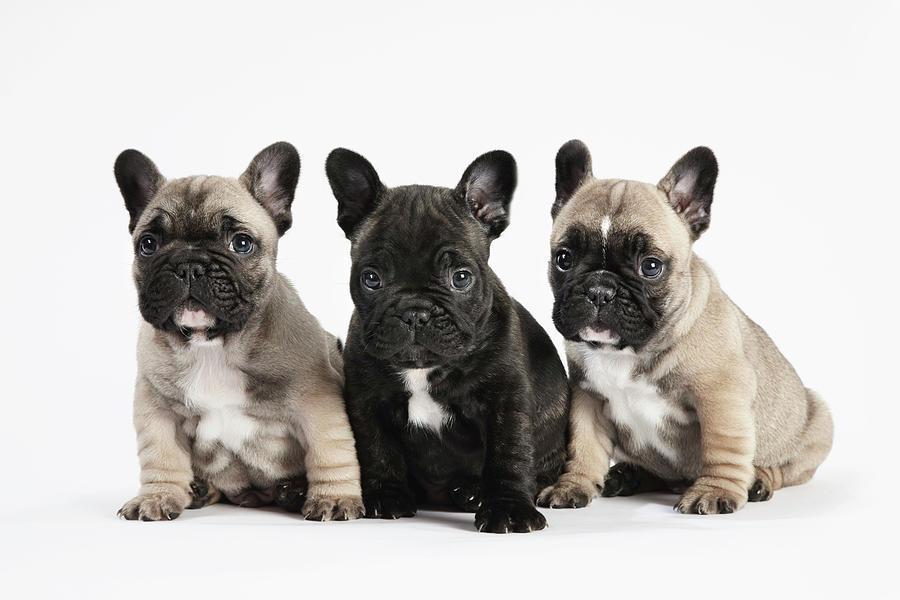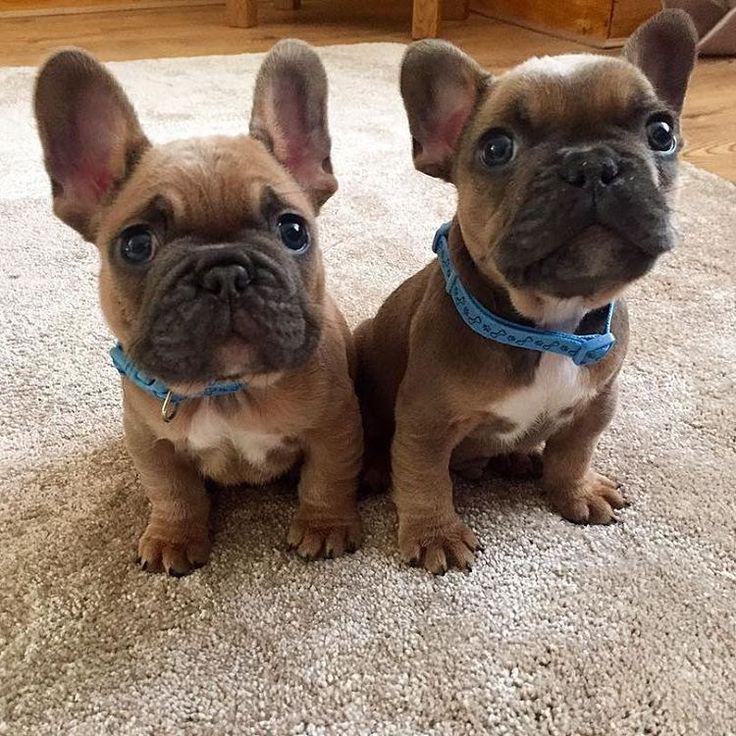The first image is the image on the left, the second image is the image on the right. Examine the images to the left and right. Is the description "An image shows a trio of puppies with a black one in the middle." accurate? Answer yes or no. Yes. The first image is the image on the left, the second image is the image on the right. For the images displayed, is the sentence "In one of the images, there are more than two puppies." factually correct? Answer yes or no. Yes. The first image is the image on the left, the second image is the image on the right. Analyze the images presented: Is the assertion "Exactly one puppy is standing alone in the grass." valid? Answer yes or no. No. The first image is the image on the left, the second image is the image on the right. Evaluate the accuracy of this statement regarding the images: "The dog in the image on the right is on grass.". Is it true? Answer yes or no. No. 